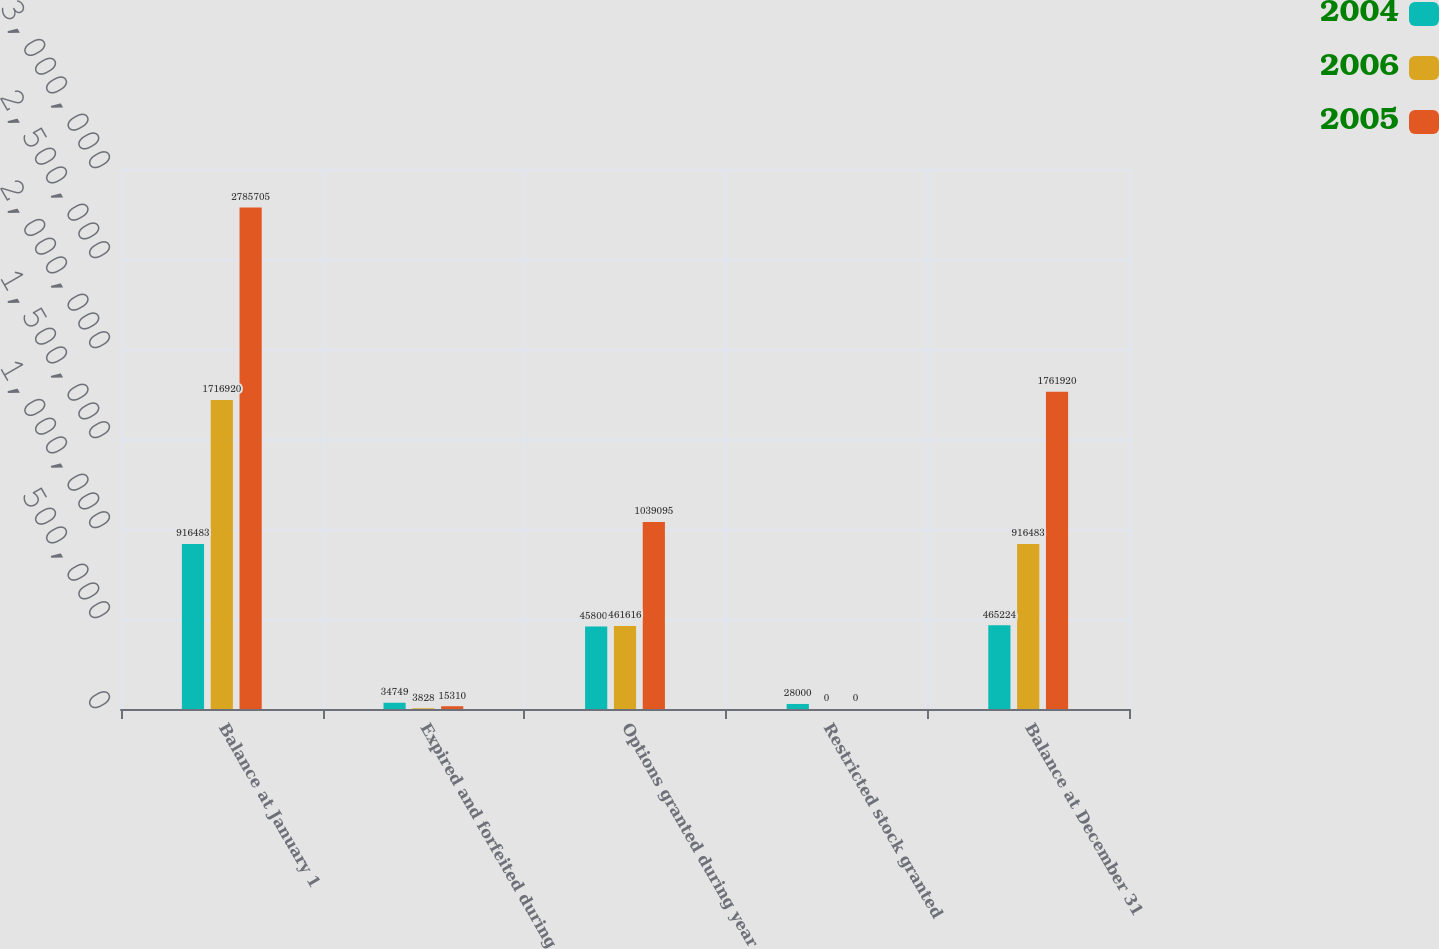Convert chart to OTSL. <chart><loc_0><loc_0><loc_500><loc_500><stacked_bar_chart><ecel><fcel>Balance at January 1<fcel>Expired and forfeited during<fcel>Options granted during year<fcel>Restricted stock granted<fcel>Balance at December 31<nl><fcel>2004<fcel>916483<fcel>34749<fcel>458008<fcel>28000<fcel>465224<nl><fcel>2006<fcel>1.71692e+06<fcel>3828<fcel>461616<fcel>0<fcel>916483<nl><fcel>2005<fcel>2.7857e+06<fcel>15310<fcel>1.0391e+06<fcel>0<fcel>1.76192e+06<nl></chart> 